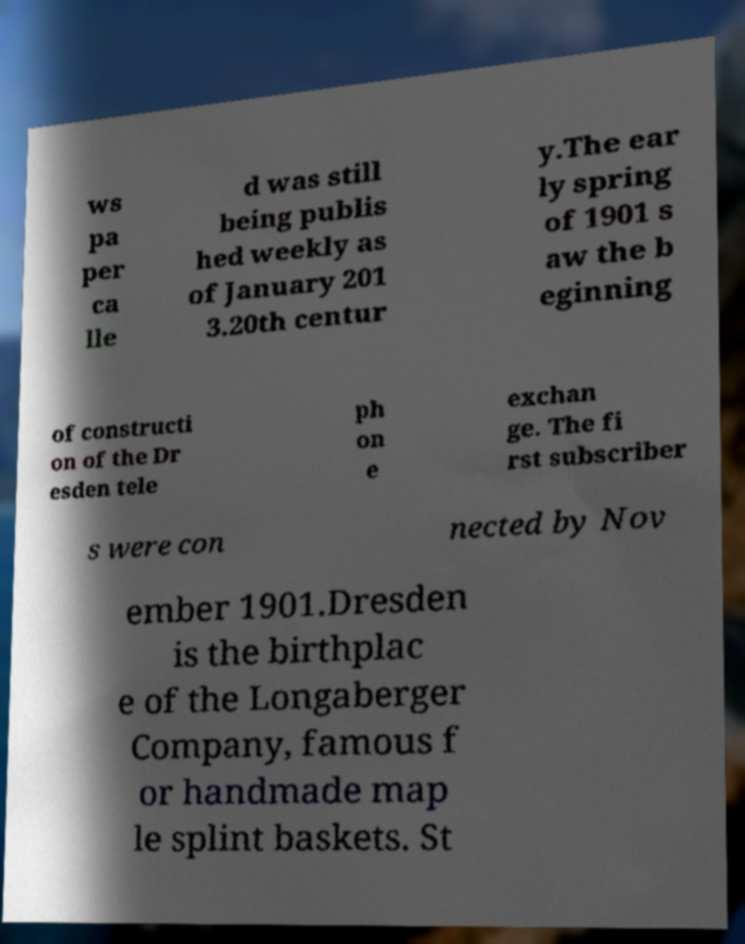Please read and relay the text visible in this image. What does it say? ws pa per ca lle d was still being publis hed weekly as of January 201 3.20th centur y.The ear ly spring of 1901 s aw the b eginning of constructi on of the Dr esden tele ph on e exchan ge. The fi rst subscriber s were con nected by Nov ember 1901.Dresden is the birthplac e of the Longaberger Company, famous f or handmade map le splint baskets. St 